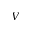<formula> <loc_0><loc_0><loc_500><loc_500>V</formula> 